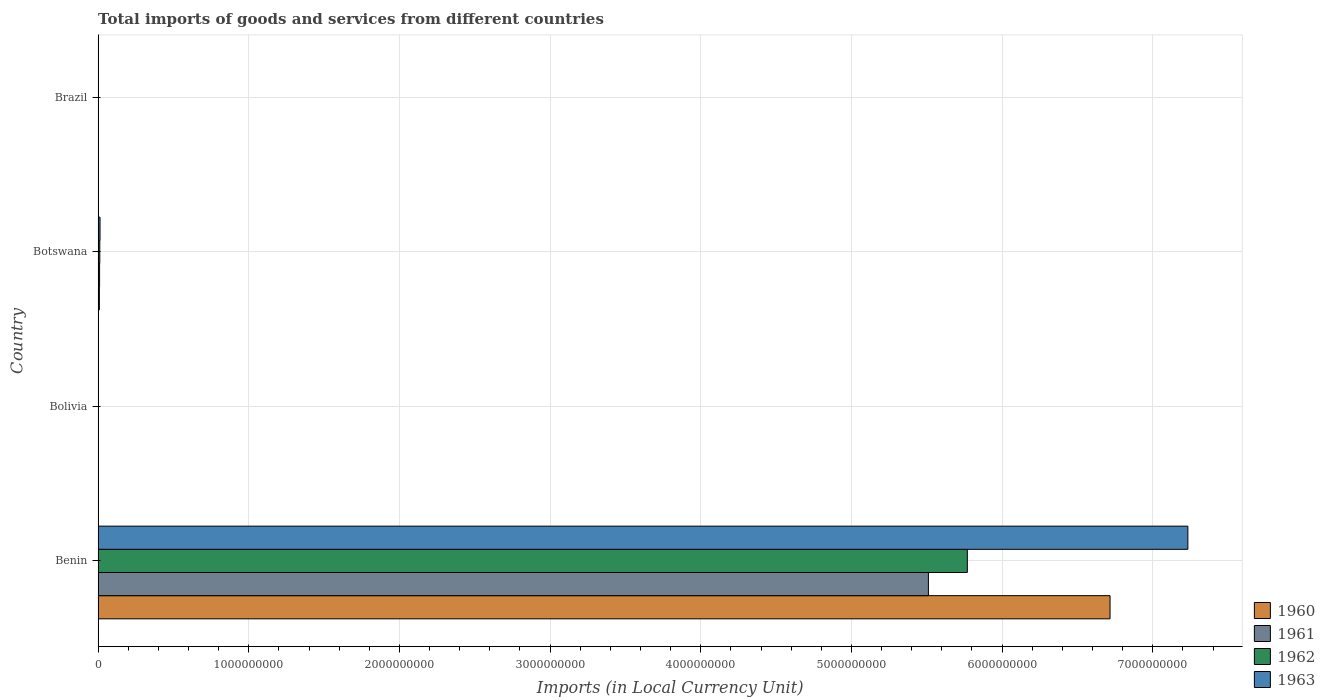How many groups of bars are there?
Your answer should be very brief. 4. How many bars are there on the 1st tick from the bottom?
Your answer should be compact. 4. What is the Amount of goods and services imports in 1960 in Brazil?
Offer a very short reply. 7.33493e-5. Across all countries, what is the maximum Amount of goods and services imports in 1962?
Provide a short and direct response. 5.77e+09. Across all countries, what is the minimum Amount of goods and services imports in 1961?
Make the answer very short. 0. In which country was the Amount of goods and services imports in 1961 maximum?
Your answer should be compact. Benin. In which country was the Amount of goods and services imports in 1960 minimum?
Provide a succinct answer. Brazil. What is the total Amount of goods and services imports in 1963 in the graph?
Make the answer very short. 7.25e+09. What is the difference between the Amount of goods and services imports in 1961 in Benin and that in Brazil?
Provide a short and direct response. 5.51e+09. What is the difference between the Amount of goods and services imports in 1960 in Bolivia and the Amount of goods and services imports in 1961 in Brazil?
Offer a terse response. 1300. What is the average Amount of goods and services imports in 1960 per country?
Provide a short and direct response. 1.68e+09. What is the ratio of the Amount of goods and services imports in 1963 in Benin to that in Bolivia?
Provide a succinct answer. 4.02e+06. Is the difference between the Amount of goods and services imports in 1960 in Benin and Botswana greater than the difference between the Amount of goods and services imports in 1961 in Benin and Botswana?
Your answer should be very brief. Yes. What is the difference between the highest and the second highest Amount of goods and services imports in 1962?
Provide a short and direct response. 5.76e+09. What is the difference between the highest and the lowest Amount of goods and services imports in 1962?
Your answer should be compact. 5.77e+09. Is it the case that in every country, the sum of the Amount of goods and services imports in 1961 and Amount of goods and services imports in 1960 is greater than the sum of Amount of goods and services imports in 1963 and Amount of goods and services imports in 1962?
Your answer should be very brief. No. Is it the case that in every country, the sum of the Amount of goods and services imports in 1962 and Amount of goods and services imports in 1963 is greater than the Amount of goods and services imports in 1961?
Provide a short and direct response. Yes. What is the difference between two consecutive major ticks on the X-axis?
Provide a short and direct response. 1.00e+09. Are the values on the major ticks of X-axis written in scientific E-notation?
Make the answer very short. No. Does the graph contain any zero values?
Your answer should be compact. No. Where does the legend appear in the graph?
Provide a short and direct response. Bottom right. What is the title of the graph?
Make the answer very short. Total imports of goods and services from different countries. Does "1982" appear as one of the legend labels in the graph?
Keep it short and to the point. No. What is the label or title of the X-axis?
Ensure brevity in your answer.  Imports (in Local Currency Unit). What is the Imports (in Local Currency Unit) of 1960 in Benin?
Keep it short and to the point. 6.72e+09. What is the Imports (in Local Currency Unit) of 1961 in Benin?
Provide a succinct answer. 5.51e+09. What is the Imports (in Local Currency Unit) of 1962 in Benin?
Offer a very short reply. 5.77e+09. What is the Imports (in Local Currency Unit) of 1963 in Benin?
Your answer should be very brief. 7.23e+09. What is the Imports (in Local Currency Unit) of 1960 in Bolivia?
Ensure brevity in your answer.  1300. What is the Imports (in Local Currency Unit) of 1961 in Bolivia?
Offer a terse response. 1300. What is the Imports (in Local Currency Unit) in 1962 in Bolivia?
Keep it short and to the point. 1600. What is the Imports (in Local Currency Unit) of 1963 in Bolivia?
Keep it short and to the point. 1800. What is the Imports (in Local Currency Unit) in 1960 in Botswana?
Give a very brief answer. 8.60e+06. What is the Imports (in Local Currency Unit) of 1961 in Botswana?
Give a very brief answer. 1.00e+07. What is the Imports (in Local Currency Unit) in 1962 in Botswana?
Ensure brevity in your answer.  1.14e+07. What is the Imports (in Local Currency Unit) in 1963 in Botswana?
Your answer should be very brief. 1.29e+07. What is the Imports (in Local Currency Unit) of 1960 in Brazil?
Ensure brevity in your answer.  7.33493e-5. What is the Imports (in Local Currency Unit) in 1961 in Brazil?
Your answer should be very brief. 0. What is the Imports (in Local Currency Unit) in 1962 in Brazil?
Your response must be concise. 0. What is the Imports (in Local Currency Unit) in 1963 in Brazil?
Keep it short and to the point. 0. Across all countries, what is the maximum Imports (in Local Currency Unit) in 1960?
Offer a terse response. 6.72e+09. Across all countries, what is the maximum Imports (in Local Currency Unit) of 1961?
Provide a succinct answer. 5.51e+09. Across all countries, what is the maximum Imports (in Local Currency Unit) in 1962?
Ensure brevity in your answer.  5.77e+09. Across all countries, what is the maximum Imports (in Local Currency Unit) of 1963?
Give a very brief answer. 7.23e+09. Across all countries, what is the minimum Imports (in Local Currency Unit) of 1960?
Your answer should be compact. 7.33493e-5. Across all countries, what is the minimum Imports (in Local Currency Unit) in 1961?
Make the answer very short. 0. Across all countries, what is the minimum Imports (in Local Currency Unit) of 1962?
Offer a very short reply. 0. Across all countries, what is the minimum Imports (in Local Currency Unit) in 1963?
Your answer should be very brief. 0. What is the total Imports (in Local Currency Unit) in 1960 in the graph?
Provide a short and direct response. 6.73e+09. What is the total Imports (in Local Currency Unit) in 1961 in the graph?
Offer a terse response. 5.52e+09. What is the total Imports (in Local Currency Unit) in 1962 in the graph?
Make the answer very short. 5.78e+09. What is the total Imports (in Local Currency Unit) of 1963 in the graph?
Your answer should be compact. 7.25e+09. What is the difference between the Imports (in Local Currency Unit) of 1960 in Benin and that in Bolivia?
Offer a very short reply. 6.72e+09. What is the difference between the Imports (in Local Currency Unit) of 1961 in Benin and that in Bolivia?
Provide a succinct answer. 5.51e+09. What is the difference between the Imports (in Local Currency Unit) of 1962 in Benin and that in Bolivia?
Ensure brevity in your answer.  5.77e+09. What is the difference between the Imports (in Local Currency Unit) of 1963 in Benin and that in Bolivia?
Your answer should be very brief. 7.23e+09. What is the difference between the Imports (in Local Currency Unit) in 1960 in Benin and that in Botswana?
Make the answer very short. 6.71e+09. What is the difference between the Imports (in Local Currency Unit) in 1961 in Benin and that in Botswana?
Your answer should be compact. 5.50e+09. What is the difference between the Imports (in Local Currency Unit) of 1962 in Benin and that in Botswana?
Your response must be concise. 5.76e+09. What is the difference between the Imports (in Local Currency Unit) of 1963 in Benin and that in Botswana?
Keep it short and to the point. 7.22e+09. What is the difference between the Imports (in Local Currency Unit) in 1960 in Benin and that in Brazil?
Your response must be concise. 6.72e+09. What is the difference between the Imports (in Local Currency Unit) in 1961 in Benin and that in Brazil?
Ensure brevity in your answer.  5.51e+09. What is the difference between the Imports (in Local Currency Unit) in 1962 in Benin and that in Brazil?
Give a very brief answer. 5.77e+09. What is the difference between the Imports (in Local Currency Unit) of 1963 in Benin and that in Brazil?
Your response must be concise. 7.23e+09. What is the difference between the Imports (in Local Currency Unit) of 1960 in Bolivia and that in Botswana?
Your response must be concise. -8.60e+06. What is the difference between the Imports (in Local Currency Unit) in 1961 in Bolivia and that in Botswana?
Your answer should be very brief. -1.00e+07. What is the difference between the Imports (in Local Currency Unit) in 1962 in Bolivia and that in Botswana?
Make the answer very short. -1.14e+07. What is the difference between the Imports (in Local Currency Unit) of 1963 in Bolivia and that in Botswana?
Your answer should be compact. -1.29e+07. What is the difference between the Imports (in Local Currency Unit) in 1960 in Bolivia and that in Brazil?
Keep it short and to the point. 1300. What is the difference between the Imports (in Local Currency Unit) in 1961 in Bolivia and that in Brazil?
Give a very brief answer. 1300. What is the difference between the Imports (in Local Currency Unit) in 1962 in Bolivia and that in Brazil?
Make the answer very short. 1600. What is the difference between the Imports (in Local Currency Unit) in 1963 in Bolivia and that in Brazil?
Your answer should be compact. 1800. What is the difference between the Imports (in Local Currency Unit) of 1960 in Botswana and that in Brazil?
Offer a very short reply. 8.60e+06. What is the difference between the Imports (in Local Currency Unit) in 1961 in Botswana and that in Brazil?
Offer a very short reply. 1.00e+07. What is the difference between the Imports (in Local Currency Unit) in 1962 in Botswana and that in Brazil?
Keep it short and to the point. 1.14e+07. What is the difference between the Imports (in Local Currency Unit) in 1963 in Botswana and that in Brazil?
Provide a succinct answer. 1.29e+07. What is the difference between the Imports (in Local Currency Unit) in 1960 in Benin and the Imports (in Local Currency Unit) in 1961 in Bolivia?
Offer a terse response. 6.72e+09. What is the difference between the Imports (in Local Currency Unit) in 1960 in Benin and the Imports (in Local Currency Unit) in 1962 in Bolivia?
Keep it short and to the point. 6.72e+09. What is the difference between the Imports (in Local Currency Unit) of 1960 in Benin and the Imports (in Local Currency Unit) of 1963 in Bolivia?
Your answer should be very brief. 6.72e+09. What is the difference between the Imports (in Local Currency Unit) in 1961 in Benin and the Imports (in Local Currency Unit) in 1962 in Bolivia?
Provide a short and direct response. 5.51e+09. What is the difference between the Imports (in Local Currency Unit) in 1961 in Benin and the Imports (in Local Currency Unit) in 1963 in Bolivia?
Provide a short and direct response. 5.51e+09. What is the difference between the Imports (in Local Currency Unit) of 1962 in Benin and the Imports (in Local Currency Unit) of 1963 in Bolivia?
Ensure brevity in your answer.  5.77e+09. What is the difference between the Imports (in Local Currency Unit) in 1960 in Benin and the Imports (in Local Currency Unit) in 1961 in Botswana?
Give a very brief answer. 6.71e+09. What is the difference between the Imports (in Local Currency Unit) of 1960 in Benin and the Imports (in Local Currency Unit) of 1962 in Botswana?
Keep it short and to the point. 6.71e+09. What is the difference between the Imports (in Local Currency Unit) of 1960 in Benin and the Imports (in Local Currency Unit) of 1963 in Botswana?
Your answer should be compact. 6.70e+09. What is the difference between the Imports (in Local Currency Unit) of 1961 in Benin and the Imports (in Local Currency Unit) of 1962 in Botswana?
Give a very brief answer. 5.50e+09. What is the difference between the Imports (in Local Currency Unit) in 1961 in Benin and the Imports (in Local Currency Unit) in 1963 in Botswana?
Your answer should be compact. 5.50e+09. What is the difference between the Imports (in Local Currency Unit) in 1962 in Benin and the Imports (in Local Currency Unit) in 1963 in Botswana?
Offer a very short reply. 5.76e+09. What is the difference between the Imports (in Local Currency Unit) in 1960 in Benin and the Imports (in Local Currency Unit) in 1961 in Brazil?
Your answer should be compact. 6.72e+09. What is the difference between the Imports (in Local Currency Unit) of 1960 in Benin and the Imports (in Local Currency Unit) of 1962 in Brazil?
Offer a terse response. 6.72e+09. What is the difference between the Imports (in Local Currency Unit) of 1960 in Benin and the Imports (in Local Currency Unit) of 1963 in Brazil?
Make the answer very short. 6.72e+09. What is the difference between the Imports (in Local Currency Unit) of 1961 in Benin and the Imports (in Local Currency Unit) of 1962 in Brazil?
Ensure brevity in your answer.  5.51e+09. What is the difference between the Imports (in Local Currency Unit) of 1961 in Benin and the Imports (in Local Currency Unit) of 1963 in Brazil?
Ensure brevity in your answer.  5.51e+09. What is the difference between the Imports (in Local Currency Unit) in 1962 in Benin and the Imports (in Local Currency Unit) in 1963 in Brazil?
Offer a very short reply. 5.77e+09. What is the difference between the Imports (in Local Currency Unit) in 1960 in Bolivia and the Imports (in Local Currency Unit) in 1961 in Botswana?
Give a very brief answer. -1.00e+07. What is the difference between the Imports (in Local Currency Unit) of 1960 in Bolivia and the Imports (in Local Currency Unit) of 1962 in Botswana?
Your answer should be compact. -1.14e+07. What is the difference between the Imports (in Local Currency Unit) in 1960 in Bolivia and the Imports (in Local Currency Unit) in 1963 in Botswana?
Provide a short and direct response. -1.29e+07. What is the difference between the Imports (in Local Currency Unit) of 1961 in Bolivia and the Imports (in Local Currency Unit) of 1962 in Botswana?
Give a very brief answer. -1.14e+07. What is the difference between the Imports (in Local Currency Unit) of 1961 in Bolivia and the Imports (in Local Currency Unit) of 1963 in Botswana?
Your answer should be very brief. -1.29e+07. What is the difference between the Imports (in Local Currency Unit) of 1962 in Bolivia and the Imports (in Local Currency Unit) of 1963 in Botswana?
Ensure brevity in your answer.  -1.29e+07. What is the difference between the Imports (in Local Currency Unit) of 1960 in Bolivia and the Imports (in Local Currency Unit) of 1961 in Brazil?
Ensure brevity in your answer.  1300. What is the difference between the Imports (in Local Currency Unit) in 1960 in Bolivia and the Imports (in Local Currency Unit) in 1962 in Brazil?
Give a very brief answer. 1300. What is the difference between the Imports (in Local Currency Unit) of 1960 in Bolivia and the Imports (in Local Currency Unit) of 1963 in Brazil?
Keep it short and to the point. 1300. What is the difference between the Imports (in Local Currency Unit) in 1961 in Bolivia and the Imports (in Local Currency Unit) in 1962 in Brazil?
Your answer should be compact. 1300. What is the difference between the Imports (in Local Currency Unit) in 1961 in Bolivia and the Imports (in Local Currency Unit) in 1963 in Brazil?
Offer a terse response. 1300. What is the difference between the Imports (in Local Currency Unit) of 1962 in Bolivia and the Imports (in Local Currency Unit) of 1963 in Brazil?
Offer a terse response. 1600. What is the difference between the Imports (in Local Currency Unit) in 1960 in Botswana and the Imports (in Local Currency Unit) in 1961 in Brazil?
Make the answer very short. 8.60e+06. What is the difference between the Imports (in Local Currency Unit) in 1960 in Botswana and the Imports (in Local Currency Unit) in 1962 in Brazil?
Provide a succinct answer. 8.60e+06. What is the difference between the Imports (in Local Currency Unit) of 1960 in Botswana and the Imports (in Local Currency Unit) of 1963 in Brazil?
Provide a short and direct response. 8.60e+06. What is the difference between the Imports (in Local Currency Unit) in 1961 in Botswana and the Imports (in Local Currency Unit) in 1962 in Brazil?
Make the answer very short. 1.00e+07. What is the difference between the Imports (in Local Currency Unit) in 1961 in Botswana and the Imports (in Local Currency Unit) in 1963 in Brazil?
Give a very brief answer. 1.00e+07. What is the difference between the Imports (in Local Currency Unit) in 1962 in Botswana and the Imports (in Local Currency Unit) in 1963 in Brazil?
Keep it short and to the point. 1.14e+07. What is the average Imports (in Local Currency Unit) in 1960 per country?
Your answer should be very brief. 1.68e+09. What is the average Imports (in Local Currency Unit) of 1961 per country?
Ensure brevity in your answer.  1.38e+09. What is the average Imports (in Local Currency Unit) of 1962 per country?
Offer a very short reply. 1.45e+09. What is the average Imports (in Local Currency Unit) in 1963 per country?
Ensure brevity in your answer.  1.81e+09. What is the difference between the Imports (in Local Currency Unit) of 1960 and Imports (in Local Currency Unit) of 1961 in Benin?
Your answer should be compact. 1.21e+09. What is the difference between the Imports (in Local Currency Unit) of 1960 and Imports (in Local Currency Unit) of 1962 in Benin?
Keep it short and to the point. 9.47e+08. What is the difference between the Imports (in Local Currency Unit) of 1960 and Imports (in Local Currency Unit) of 1963 in Benin?
Provide a succinct answer. -5.17e+08. What is the difference between the Imports (in Local Currency Unit) in 1961 and Imports (in Local Currency Unit) in 1962 in Benin?
Your response must be concise. -2.58e+08. What is the difference between the Imports (in Local Currency Unit) in 1961 and Imports (in Local Currency Unit) in 1963 in Benin?
Keep it short and to the point. -1.72e+09. What is the difference between the Imports (in Local Currency Unit) in 1962 and Imports (in Local Currency Unit) in 1963 in Benin?
Your answer should be very brief. -1.46e+09. What is the difference between the Imports (in Local Currency Unit) of 1960 and Imports (in Local Currency Unit) of 1961 in Bolivia?
Your answer should be compact. 0. What is the difference between the Imports (in Local Currency Unit) of 1960 and Imports (in Local Currency Unit) of 1962 in Bolivia?
Provide a short and direct response. -300. What is the difference between the Imports (in Local Currency Unit) of 1960 and Imports (in Local Currency Unit) of 1963 in Bolivia?
Your answer should be compact. -500. What is the difference between the Imports (in Local Currency Unit) in 1961 and Imports (in Local Currency Unit) in 1962 in Bolivia?
Provide a succinct answer. -300. What is the difference between the Imports (in Local Currency Unit) in 1961 and Imports (in Local Currency Unit) in 1963 in Bolivia?
Your answer should be compact. -500. What is the difference between the Imports (in Local Currency Unit) in 1962 and Imports (in Local Currency Unit) in 1963 in Bolivia?
Keep it short and to the point. -200. What is the difference between the Imports (in Local Currency Unit) of 1960 and Imports (in Local Currency Unit) of 1961 in Botswana?
Make the answer very short. -1.40e+06. What is the difference between the Imports (in Local Currency Unit) in 1960 and Imports (in Local Currency Unit) in 1962 in Botswana?
Give a very brief answer. -2.80e+06. What is the difference between the Imports (in Local Currency Unit) of 1960 and Imports (in Local Currency Unit) of 1963 in Botswana?
Offer a terse response. -4.30e+06. What is the difference between the Imports (in Local Currency Unit) of 1961 and Imports (in Local Currency Unit) of 1962 in Botswana?
Offer a terse response. -1.40e+06. What is the difference between the Imports (in Local Currency Unit) in 1961 and Imports (in Local Currency Unit) in 1963 in Botswana?
Your response must be concise. -2.90e+06. What is the difference between the Imports (in Local Currency Unit) of 1962 and Imports (in Local Currency Unit) of 1963 in Botswana?
Ensure brevity in your answer.  -1.50e+06. What is the difference between the Imports (in Local Currency Unit) of 1960 and Imports (in Local Currency Unit) of 1962 in Brazil?
Give a very brief answer. -0. What is the difference between the Imports (in Local Currency Unit) in 1960 and Imports (in Local Currency Unit) in 1963 in Brazil?
Offer a very short reply. -0. What is the difference between the Imports (in Local Currency Unit) in 1961 and Imports (in Local Currency Unit) in 1963 in Brazil?
Your answer should be compact. -0. What is the difference between the Imports (in Local Currency Unit) of 1962 and Imports (in Local Currency Unit) of 1963 in Brazil?
Ensure brevity in your answer.  -0. What is the ratio of the Imports (in Local Currency Unit) in 1960 in Benin to that in Bolivia?
Make the answer very short. 5.17e+06. What is the ratio of the Imports (in Local Currency Unit) in 1961 in Benin to that in Bolivia?
Offer a very short reply. 4.24e+06. What is the ratio of the Imports (in Local Currency Unit) in 1962 in Benin to that in Bolivia?
Provide a short and direct response. 3.61e+06. What is the ratio of the Imports (in Local Currency Unit) in 1963 in Benin to that in Bolivia?
Your response must be concise. 4.02e+06. What is the ratio of the Imports (in Local Currency Unit) in 1960 in Benin to that in Botswana?
Your answer should be compact. 781. What is the ratio of the Imports (in Local Currency Unit) of 1961 in Benin to that in Botswana?
Offer a very short reply. 551.1. What is the ratio of the Imports (in Local Currency Unit) in 1962 in Benin to that in Botswana?
Ensure brevity in your answer.  506.09. What is the ratio of the Imports (in Local Currency Unit) in 1963 in Benin to that in Botswana?
Your answer should be very brief. 560.71. What is the ratio of the Imports (in Local Currency Unit) in 1960 in Benin to that in Brazil?
Offer a very short reply. 9.16e+13. What is the ratio of the Imports (in Local Currency Unit) of 1961 in Benin to that in Brazil?
Your answer should be very brief. 5.03e+13. What is the ratio of the Imports (in Local Currency Unit) of 1962 in Benin to that in Brazil?
Your response must be concise. 3.96e+13. What is the ratio of the Imports (in Local Currency Unit) of 1963 in Benin to that in Brazil?
Keep it short and to the point. 1.65e+13. What is the ratio of the Imports (in Local Currency Unit) in 1960 in Bolivia to that in Brazil?
Your answer should be very brief. 1.77e+07. What is the ratio of the Imports (in Local Currency Unit) in 1961 in Bolivia to that in Brazil?
Provide a short and direct response. 1.19e+07. What is the ratio of the Imports (in Local Currency Unit) in 1962 in Bolivia to that in Brazil?
Your answer should be very brief. 1.10e+07. What is the ratio of the Imports (in Local Currency Unit) in 1963 in Bolivia to that in Brazil?
Provide a succinct answer. 4.11e+06. What is the ratio of the Imports (in Local Currency Unit) in 1960 in Botswana to that in Brazil?
Offer a terse response. 1.17e+11. What is the ratio of the Imports (in Local Currency Unit) in 1961 in Botswana to that in Brazil?
Give a very brief answer. 9.13e+1. What is the ratio of the Imports (in Local Currency Unit) of 1962 in Botswana to that in Brazil?
Keep it short and to the point. 7.82e+1. What is the ratio of the Imports (in Local Currency Unit) in 1963 in Botswana to that in Brazil?
Make the answer very short. 2.94e+1. What is the difference between the highest and the second highest Imports (in Local Currency Unit) in 1960?
Provide a succinct answer. 6.71e+09. What is the difference between the highest and the second highest Imports (in Local Currency Unit) in 1961?
Provide a succinct answer. 5.50e+09. What is the difference between the highest and the second highest Imports (in Local Currency Unit) in 1962?
Offer a very short reply. 5.76e+09. What is the difference between the highest and the second highest Imports (in Local Currency Unit) in 1963?
Ensure brevity in your answer.  7.22e+09. What is the difference between the highest and the lowest Imports (in Local Currency Unit) of 1960?
Your response must be concise. 6.72e+09. What is the difference between the highest and the lowest Imports (in Local Currency Unit) of 1961?
Your answer should be compact. 5.51e+09. What is the difference between the highest and the lowest Imports (in Local Currency Unit) in 1962?
Give a very brief answer. 5.77e+09. What is the difference between the highest and the lowest Imports (in Local Currency Unit) of 1963?
Offer a very short reply. 7.23e+09. 